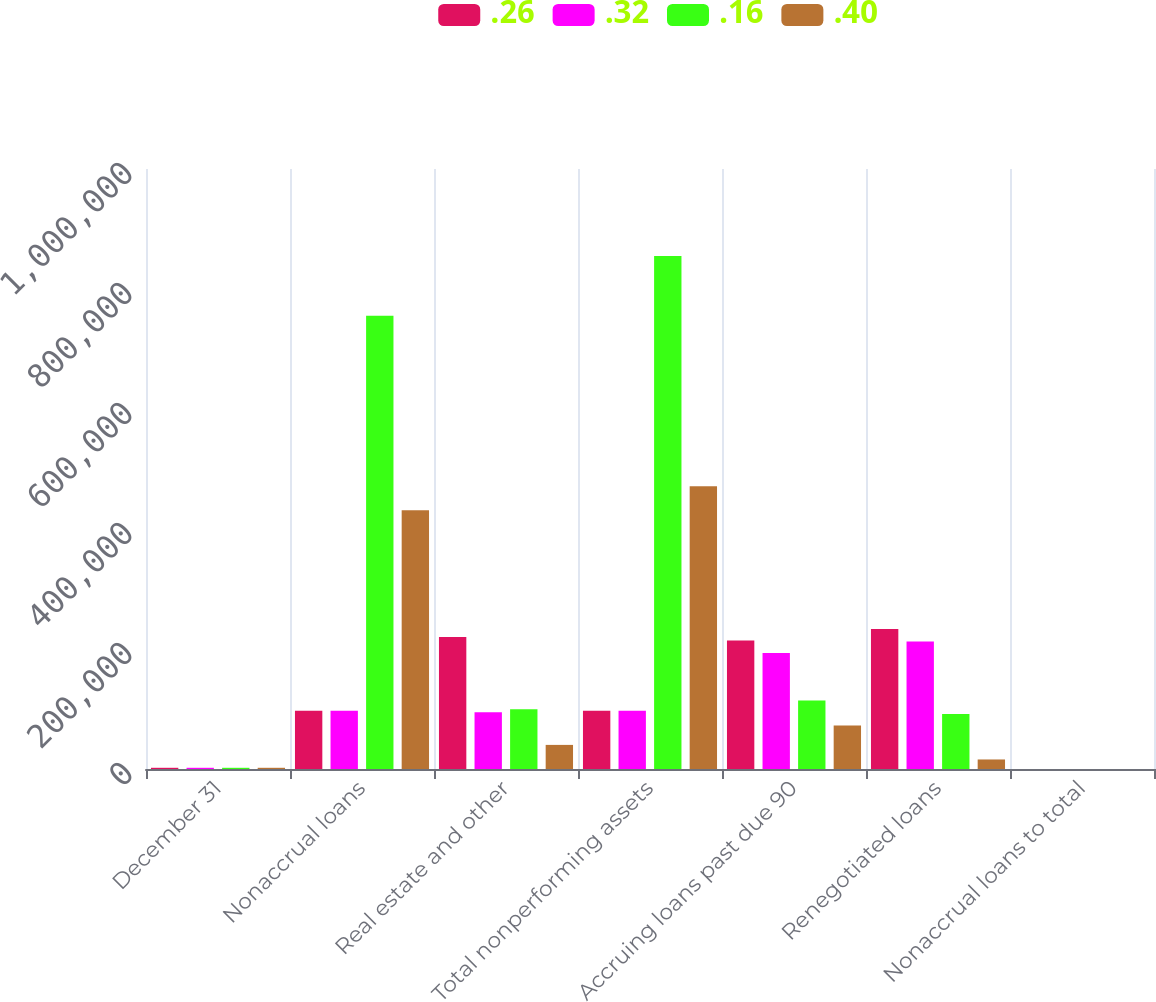<chart> <loc_0><loc_0><loc_500><loc_500><stacked_bar_chart><ecel><fcel>December 31<fcel>Nonaccrual loans<fcel>Real estate and other<fcel>Total nonperforming assets<fcel>Accruing loans past due 90<fcel>Renegotiated loans<fcel>Nonaccrual loans to total<nl><fcel>0.26<fcel>2010<fcel>97110.5<fcel>220049<fcel>97110.5<fcel>214111<fcel>233342<fcel>2.38<nl><fcel>0.32<fcel>2009<fcel>97110.5<fcel>94604<fcel>97110.5<fcel>193495<fcel>212548<fcel>2.56<nl><fcel>0.16<fcel>2008<fcel>755397<fcel>99617<fcel>855014<fcel>114183<fcel>91575<fcel>1.54<nl><fcel>0.4<fcel>2007<fcel>431282<fcel>40175<fcel>471457<fcel>72705<fcel>15884<fcel>0.9<nl></chart> 